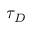<formula> <loc_0><loc_0><loc_500><loc_500>\tau _ { D }</formula> 